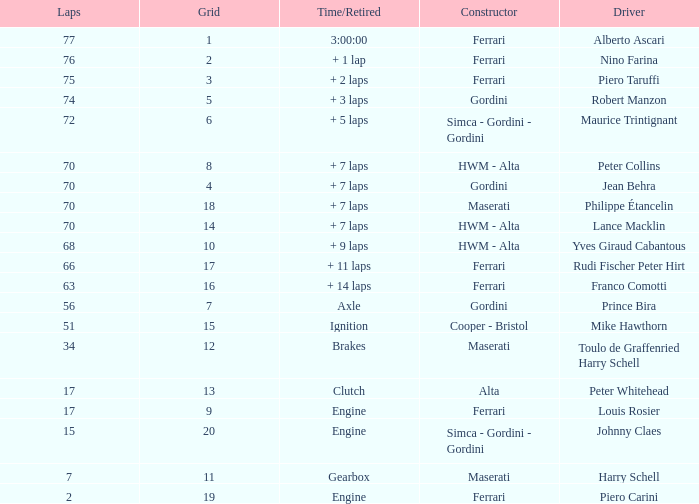How many grids for peter collins? 1.0. 